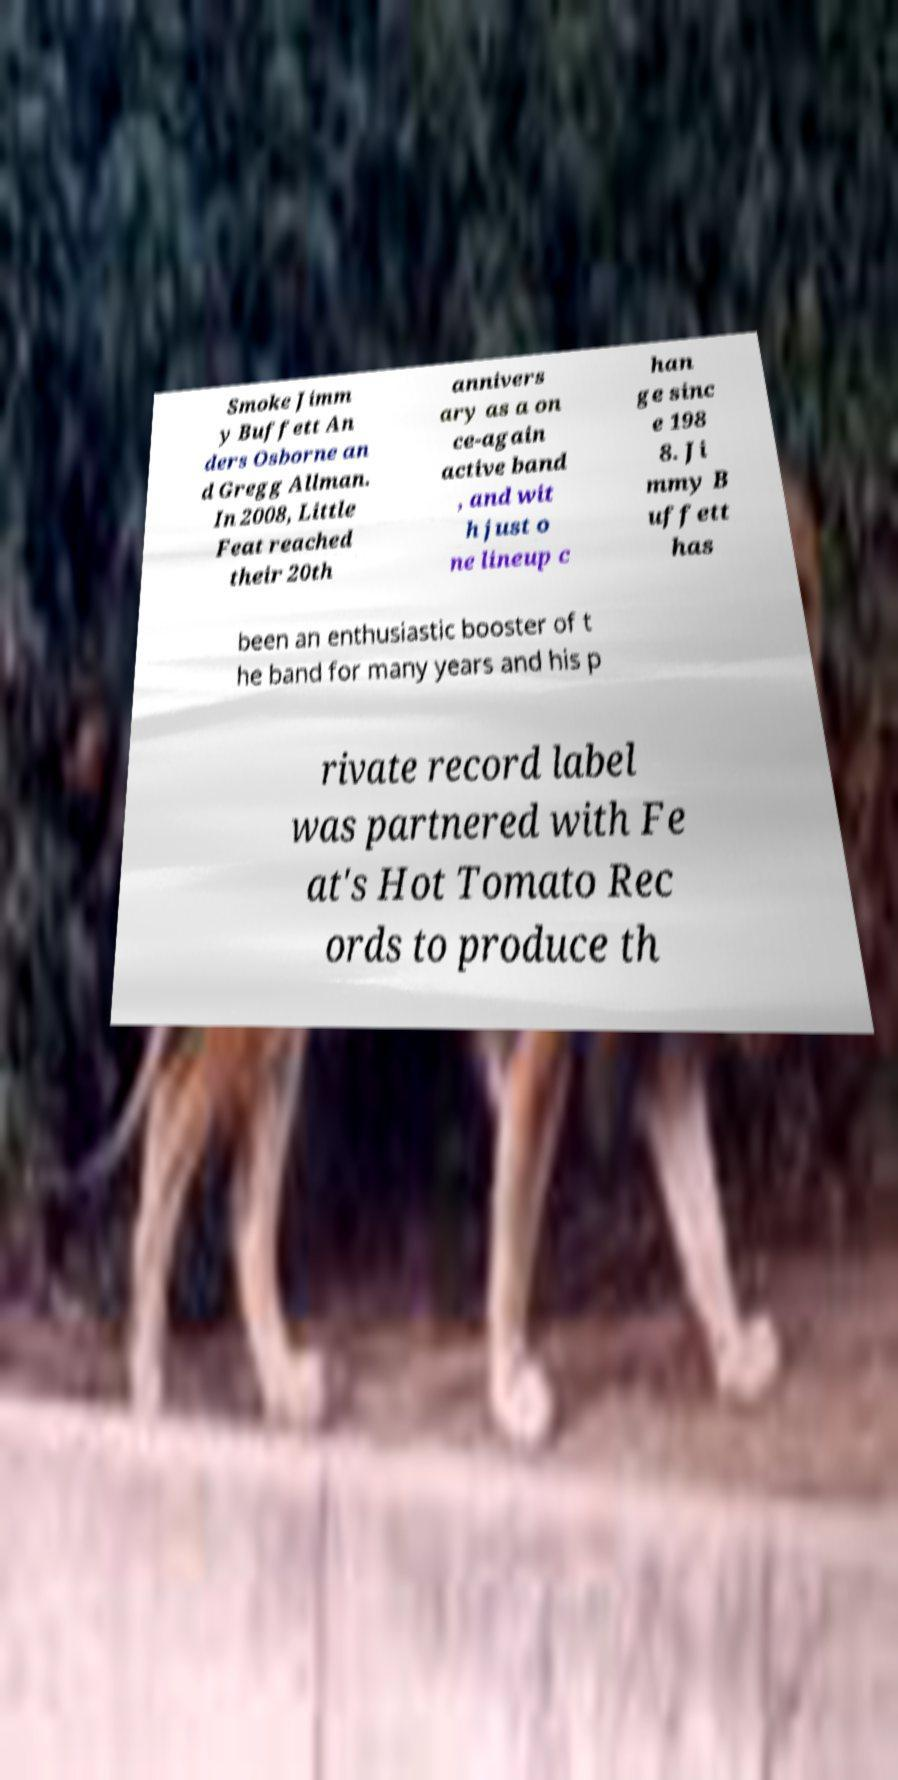What messages or text are displayed in this image? I need them in a readable, typed format. Smoke Jimm y Buffett An ders Osborne an d Gregg Allman. In 2008, Little Feat reached their 20th annivers ary as a on ce-again active band , and wit h just o ne lineup c han ge sinc e 198 8. Ji mmy B uffett has been an enthusiastic booster of t he band for many years and his p rivate record label was partnered with Fe at's Hot Tomato Rec ords to produce th 